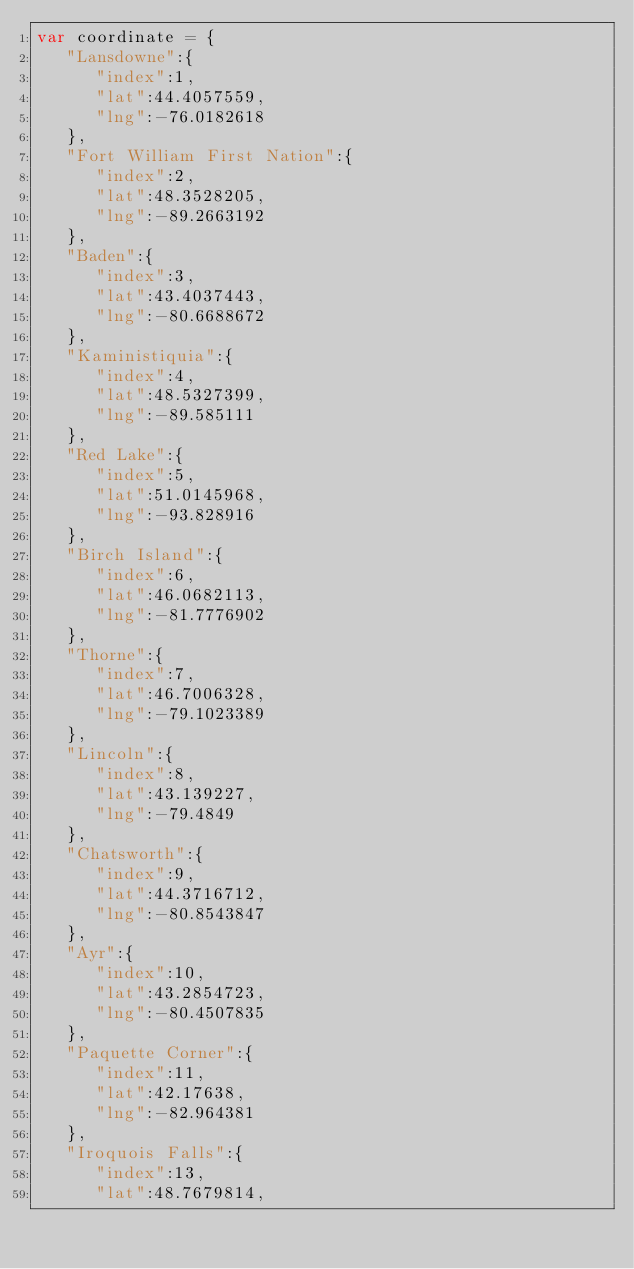<code> <loc_0><loc_0><loc_500><loc_500><_JavaScript_>var coordinate = {
   "Lansdowne":{
      "index":1,
      "lat":44.4057559,
      "lng":-76.0182618
   },
   "Fort William First Nation":{
      "index":2,
      "lat":48.3528205,
      "lng":-89.2663192
   },
   "Baden":{
      "index":3,
      "lat":43.4037443,
      "lng":-80.6688672
   },
   "Kaministiquia":{
      "index":4,
      "lat":48.5327399,
      "lng":-89.585111
   },
   "Red Lake":{
      "index":5,
      "lat":51.0145968,
      "lng":-93.828916
   },
   "Birch Island":{
      "index":6,
      "lat":46.0682113,
      "lng":-81.7776902
   },
   "Thorne":{
      "index":7,
      "lat":46.7006328,
      "lng":-79.1023389
   },
   "Lincoln":{
      "index":8,
      "lat":43.139227,
      "lng":-79.4849
   },
   "Chatsworth":{
      "index":9,
      "lat":44.3716712,
      "lng":-80.8543847
   },
   "Ayr":{
      "index":10,
      "lat":43.2854723,
      "lng":-80.4507835
   },
   "Paquette Corner":{
      "index":11,
      "lat":42.17638,
      "lng":-82.964381
   },
   "Iroquois Falls":{
      "index":13,
      "lat":48.7679814,</code> 